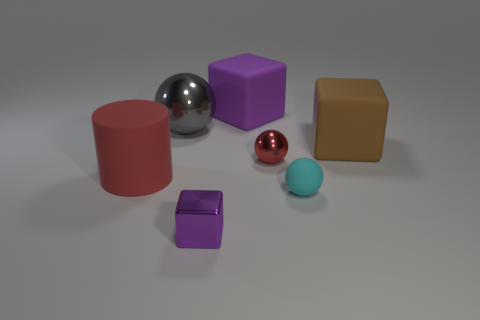Are there more matte blocks than large blue blocks? Yes, there are more matte blocks in the image. To elaborate, we have one large matte red cylinder, one large matte brown cube, and two smaller matte blocks, one purple and one violet, versus just one large blue block. The matte textures lack the glossy sheen that the two spherical objects and the small blue ball exhibit. 